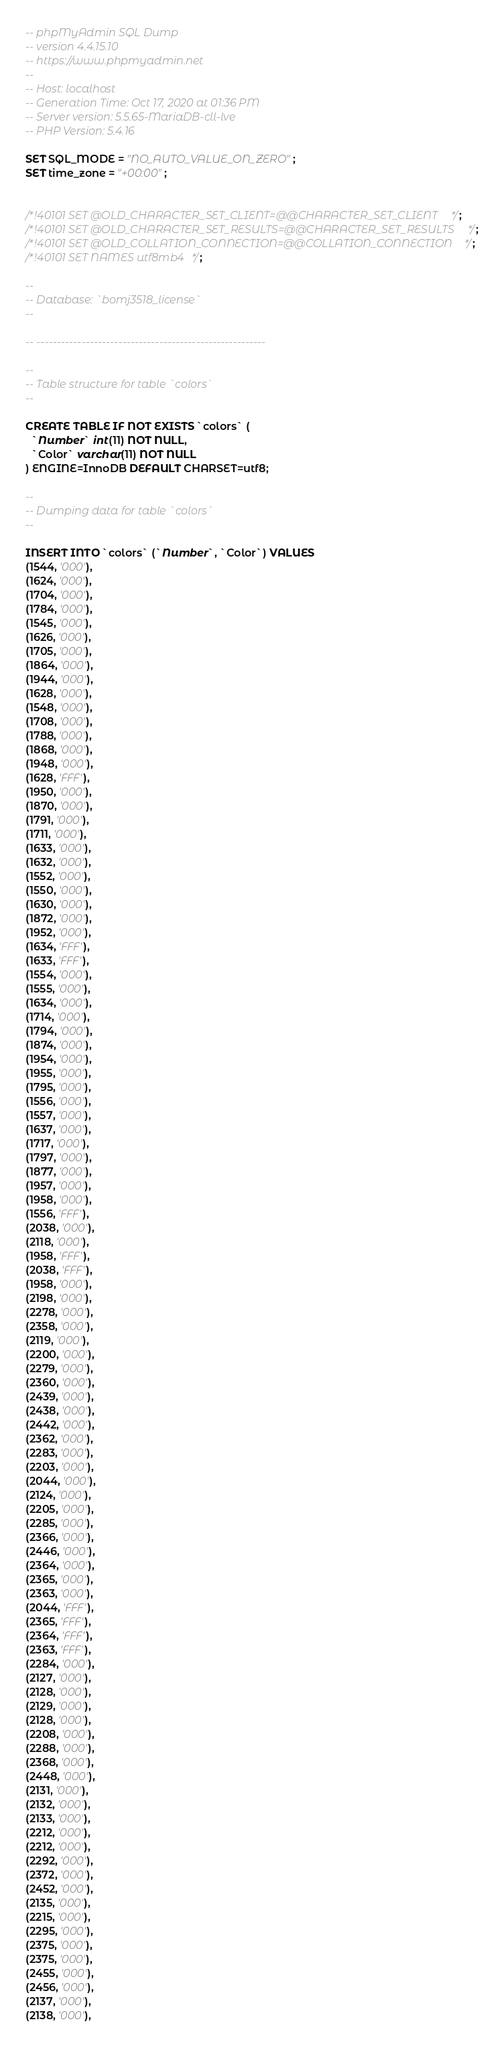<code> <loc_0><loc_0><loc_500><loc_500><_SQL_>-- phpMyAdmin SQL Dump
-- version 4.4.15.10
-- https://www.phpmyadmin.net
--
-- Host: localhost
-- Generation Time: Oct 17, 2020 at 01:36 PM
-- Server version: 5.5.65-MariaDB-cll-lve
-- PHP Version: 5.4.16

SET SQL_MODE = "NO_AUTO_VALUE_ON_ZERO";
SET time_zone = "+00:00";


/*!40101 SET @OLD_CHARACTER_SET_CLIENT=@@CHARACTER_SET_CLIENT */;
/*!40101 SET @OLD_CHARACTER_SET_RESULTS=@@CHARACTER_SET_RESULTS */;
/*!40101 SET @OLD_COLLATION_CONNECTION=@@COLLATION_CONNECTION */;
/*!40101 SET NAMES utf8mb4 */;

--
-- Database: `bomj3518_license`
--

-- --------------------------------------------------------

--
-- Table structure for table `colors`
--

CREATE TABLE IF NOT EXISTS `colors` (
  `Number` int(11) NOT NULL,
  `Color` varchar(11) NOT NULL
) ENGINE=InnoDB DEFAULT CHARSET=utf8;

--
-- Dumping data for table `colors`
--

INSERT INTO `colors` (`Number`, `Color`) VALUES
(1544, '000'),
(1624, '000'),
(1704, '000'),
(1784, '000'),
(1545, '000'),
(1626, '000'),
(1705, '000'),
(1864, '000'),
(1944, '000'),
(1628, '000'),
(1548, '000'),
(1708, '000'),
(1788, '000'),
(1868, '000'),
(1948, '000'),
(1628, 'FFF'),
(1950, '000'),
(1870, '000'),
(1791, '000'),
(1711, '000'),
(1633, '000'),
(1632, '000'),
(1552, '000'),
(1550, '000'),
(1630, '000'),
(1872, '000'),
(1952, '000'),
(1634, 'FFF'),
(1633, 'FFF'),
(1554, '000'),
(1555, '000'),
(1634, '000'),
(1714, '000'),
(1794, '000'),
(1874, '000'),
(1954, '000'),
(1955, '000'),
(1795, '000'),
(1556, '000'),
(1557, '000'),
(1637, '000'),
(1717, '000'),
(1797, '000'),
(1877, '000'),
(1957, '000'),
(1958, '000'),
(1556, 'FFF'),
(2038, '000'),
(2118, '000'),
(1958, 'FFF'),
(2038, 'FFF'),
(1958, '000'),
(2198, '000'),
(2278, '000'),
(2358, '000'),
(2119, '000'),
(2200, '000'),
(2279, '000'),
(2360, '000'),
(2439, '000'),
(2438, '000'),
(2442, '000'),
(2362, '000'),
(2283, '000'),
(2203, '000'),
(2044, '000'),
(2124, '000'),
(2205, '000'),
(2285, '000'),
(2366, '000'),
(2446, '000'),
(2364, '000'),
(2365, '000'),
(2363, '000'),
(2044, 'FFF'),
(2365, 'FFF'),
(2364, 'FFF'),
(2363, 'FFF'),
(2284, '000'),
(2127, '000'),
(2128, '000'),
(2129, '000'),
(2128, '000'),
(2208, '000'),
(2288, '000'),
(2368, '000'),
(2448, '000'),
(2131, '000'),
(2132, '000'),
(2133, '000'),
(2212, '000'),
(2212, '000'),
(2292, '000'),
(2372, '000'),
(2452, '000'),
(2135, '000'),
(2215, '000'),
(2295, '000'),
(2375, '000'),
(2375, '000'),
(2455, '000'),
(2456, '000'),
(2137, '000'),
(2138, '000'),</code> 